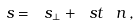Convert formula to latex. <formula><loc_0><loc_0><loc_500><loc_500>\ s = \ s _ { \perp } + \ s t \, \ n \, ,</formula> 